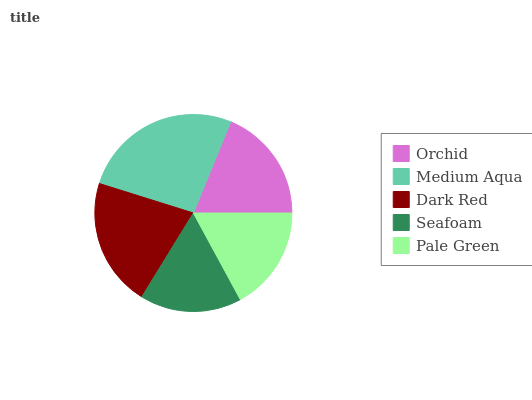Is Seafoam the minimum?
Answer yes or no. Yes. Is Medium Aqua the maximum?
Answer yes or no. Yes. Is Dark Red the minimum?
Answer yes or no. No. Is Dark Red the maximum?
Answer yes or no. No. Is Medium Aqua greater than Dark Red?
Answer yes or no. Yes. Is Dark Red less than Medium Aqua?
Answer yes or no. Yes. Is Dark Red greater than Medium Aqua?
Answer yes or no. No. Is Medium Aqua less than Dark Red?
Answer yes or no. No. Is Orchid the high median?
Answer yes or no. Yes. Is Orchid the low median?
Answer yes or no. Yes. Is Medium Aqua the high median?
Answer yes or no. No. Is Dark Red the low median?
Answer yes or no. No. 